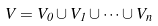Convert formula to latex. <formula><loc_0><loc_0><loc_500><loc_500>V = V _ { 0 } \cup V _ { 1 } \cup \cdots \cup V _ { n }</formula> 